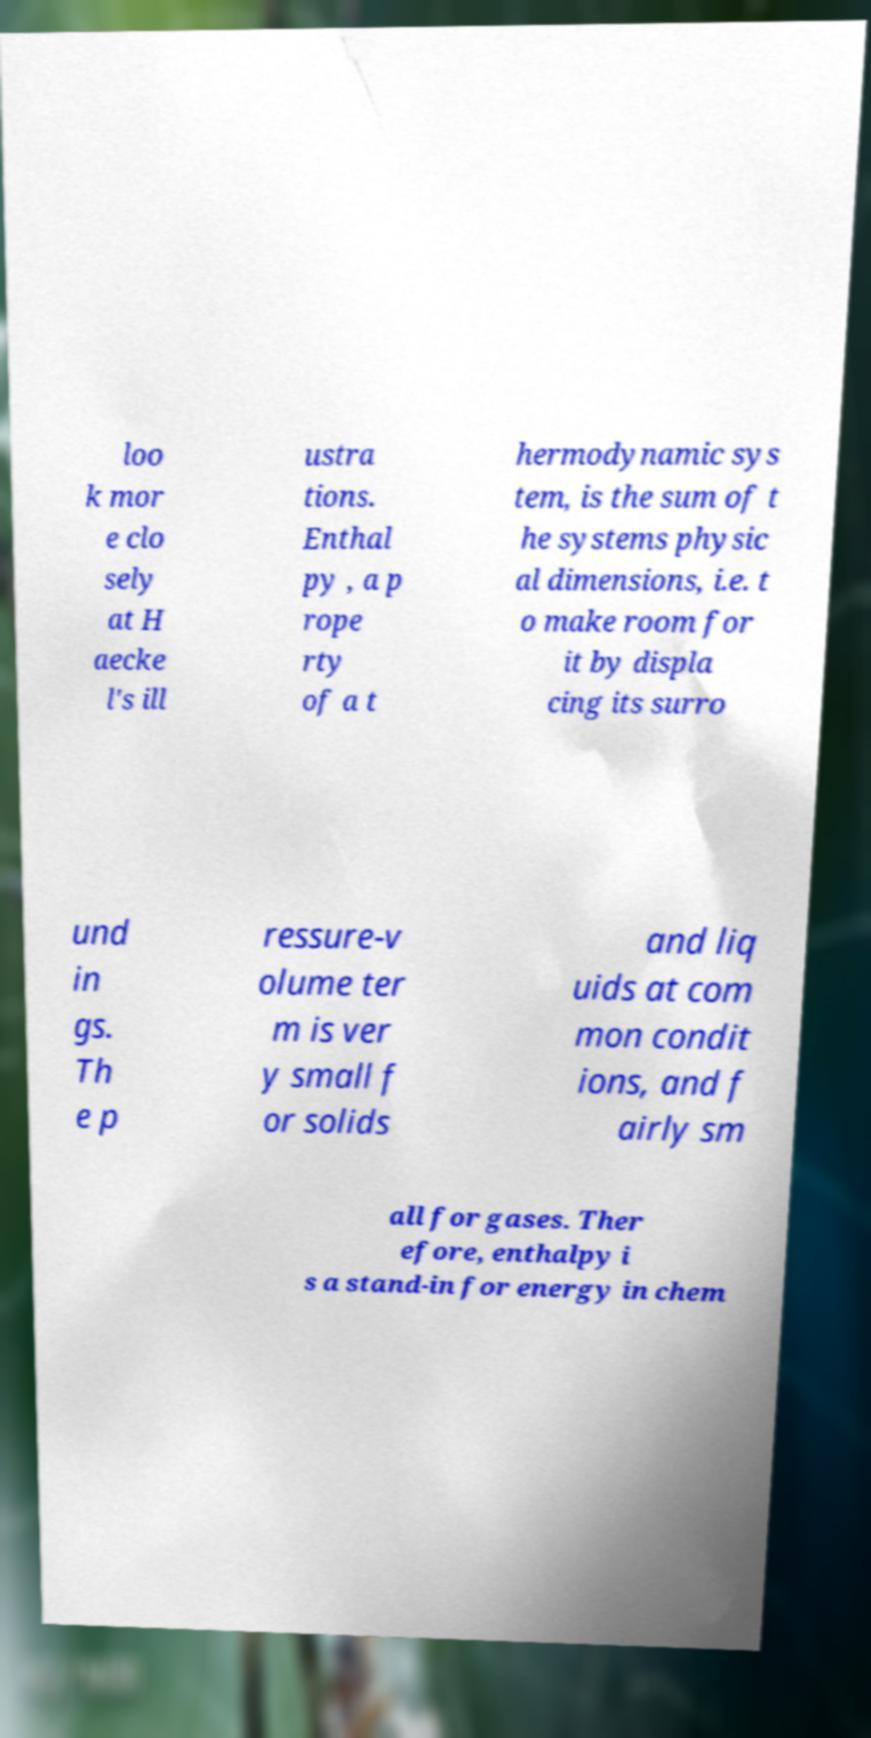Please identify and transcribe the text found in this image. loo k mor e clo sely at H aecke l's ill ustra tions. Enthal py , a p rope rty of a t hermodynamic sys tem, is the sum of t he systems physic al dimensions, i.e. t o make room for it by displa cing its surro und in gs. Th e p ressure-v olume ter m is ver y small f or solids and liq uids at com mon condit ions, and f airly sm all for gases. Ther efore, enthalpy i s a stand-in for energy in chem 